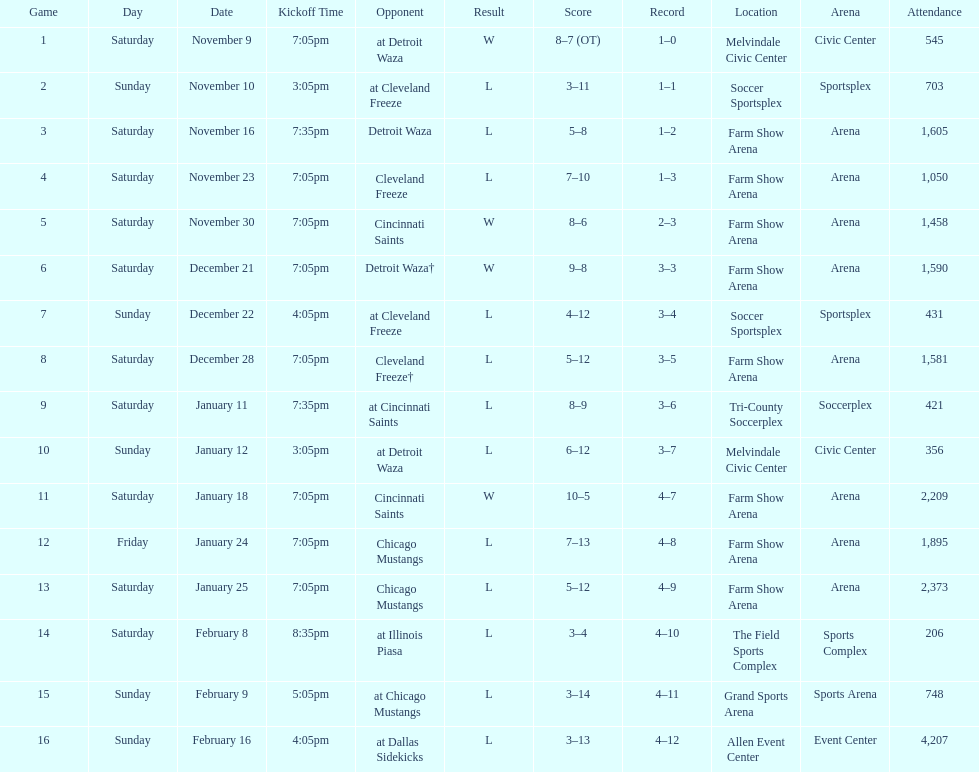Which opponent is listed first in the table? Detroit Waza. 